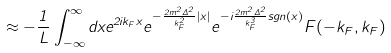<formula> <loc_0><loc_0><loc_500><loc_500>\approx - \frac { 1 } { L } \int _ { - \infty } ^ { \infty } d x e ^ { 2 i k _ { F } x } e ^ { - \frac { 2 m ^ { 2 } \Delta ^ { 2 } } { k ^ { 2 } _ { F } } | x | } e ^ { - i \frac { 2 m ^ { 2 } \Delta ^ { 2 } } { k ^ { 3 } _ { F } } s g n ( x ) } F ( - k _ { F } , k _ { F } )</formula> 